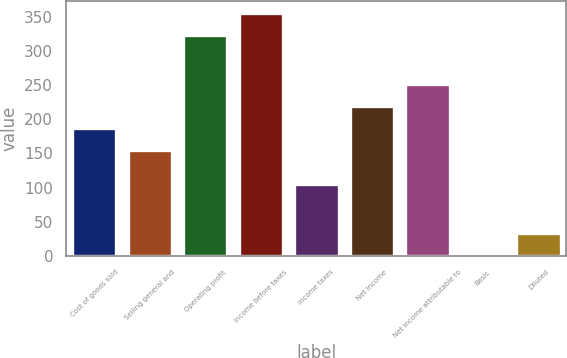<chart> <loc_0><loc_0><loc_500><loc_500><bar_chart><fcel>Cost of goods sold<fcel>Selling general and<fcel>Operating profit<fcel>Income before taxes<fcel>Income taxes<fcel>Net Income<fcel>Net income attributable to<fcel>Basic<fcel>Diluted<nl><fcel>187.24<fcel>155<fcel>323<fcel>355.24<fcel>105<fcel>219.48<fcel>251.72<fcel>0.61<fcel>32.85<nl></chart> 